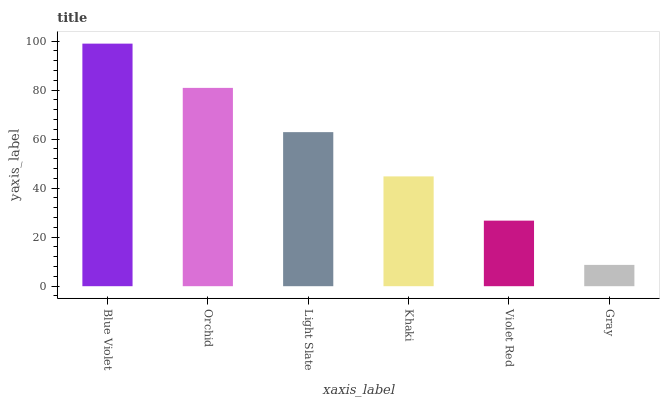Is Gray the minimum?
Answer yes or no. Yes. Is Blue Violet the maximum?
Answer yes or no. Yes. Is Orchid the minimum?
Answer yes or no. No. Is Orchid the maximum?
Answer yes or no. No. Is Blue Violet greater than Orchid?
Answer yes or no. Yes. Is Orchid less than Blue Violet?
Answer yes or no. Yes. Is Orchid greater than Blue Violet?
Answer yes or no. No. Is Blue Violet less than Orchid?
Answer yes or no. No. Is Light Slate the high median?
Answer yes or no. Yes. Is Khaki the low median?
Answer yes or no. Yes. Is Orchid the high median?
Answer yes or no. No. Is Orchid the low median?
Answer yes or no. No. 